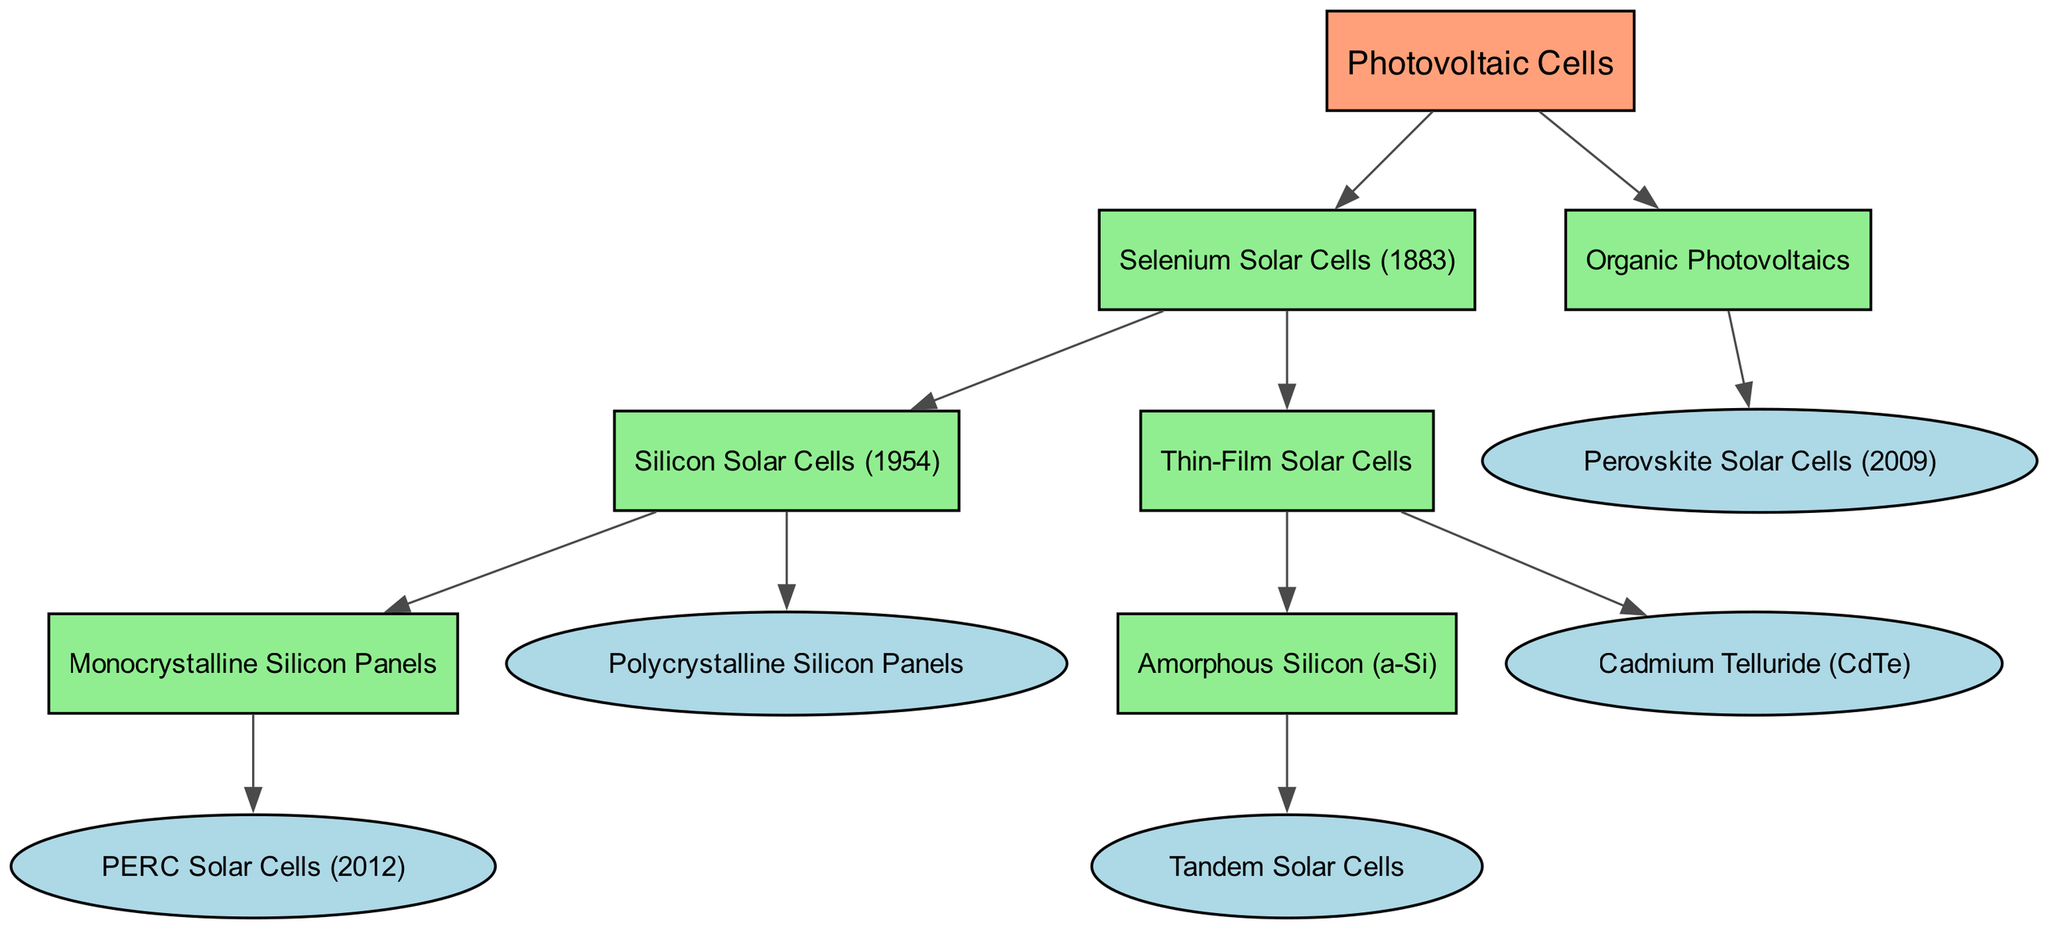What is the root node of the diagram? The root node is labeled "Photovoltaic Cells." This is the topmost node from which all other nodes branch out.
Answer: Photovoltaic Cells How many main branches are connected to the root node? There are two main branches stemming from the root node: one for "Selenium Solar Cells" and the other for "Organic Photovoltaics." Counting these branches gives a total of two.
Answer: 2 What technology was developed first in the family tree? The first technology mentioned in the diagram is "Selenium Solar Cells," which was developed in 1883, indicating it is the earliest in this lineage.
Answer: Selenium Solar Cells Which type of solar cell is a child of "Thin-Film Solar Cells"? The diagram shows that "Cadmium Telluride (CdTe)" is a child of "Thin-Film Solar Cells." This can be seen directly under the "Thin-Film Solar Cells" node.
Answer: Cadmium Telluride (CdTe) What is the relationship between "Silicon Solar Cells" and "Monocrystalline Silicon Panels"? "Monocrystalline Silicon Panels" is a child node of "Silicon Solar Cells," which means it is a type or technology that originates from "Silicon Solar Cells." This illustrates a hierarchical relationship.
Answer: Child How many children does "Selenium Solar Cells" have? "Selenium Solar Cells" has two children: "Silicon Solar Cells" and "Thin-Film Solar Cells." Counting these will provide the total of two offspring.
Answer: 2 Which technology was introduced in 2012? The technology introduced in 2012 is noted as "PERC Solar Cells," which is a specific advancement under the "Monocrystalline Silicon Panels" category.
Answer: PERC Solar Cells Which type of cell has a tandem version? The diagram indicates that "Amorphous Silicon (a-Si)" has a tandem version called "Tandem Solar Cells," showing a specific evolution of this technology.
Answer: Amorphous Silicon (a-Si) 